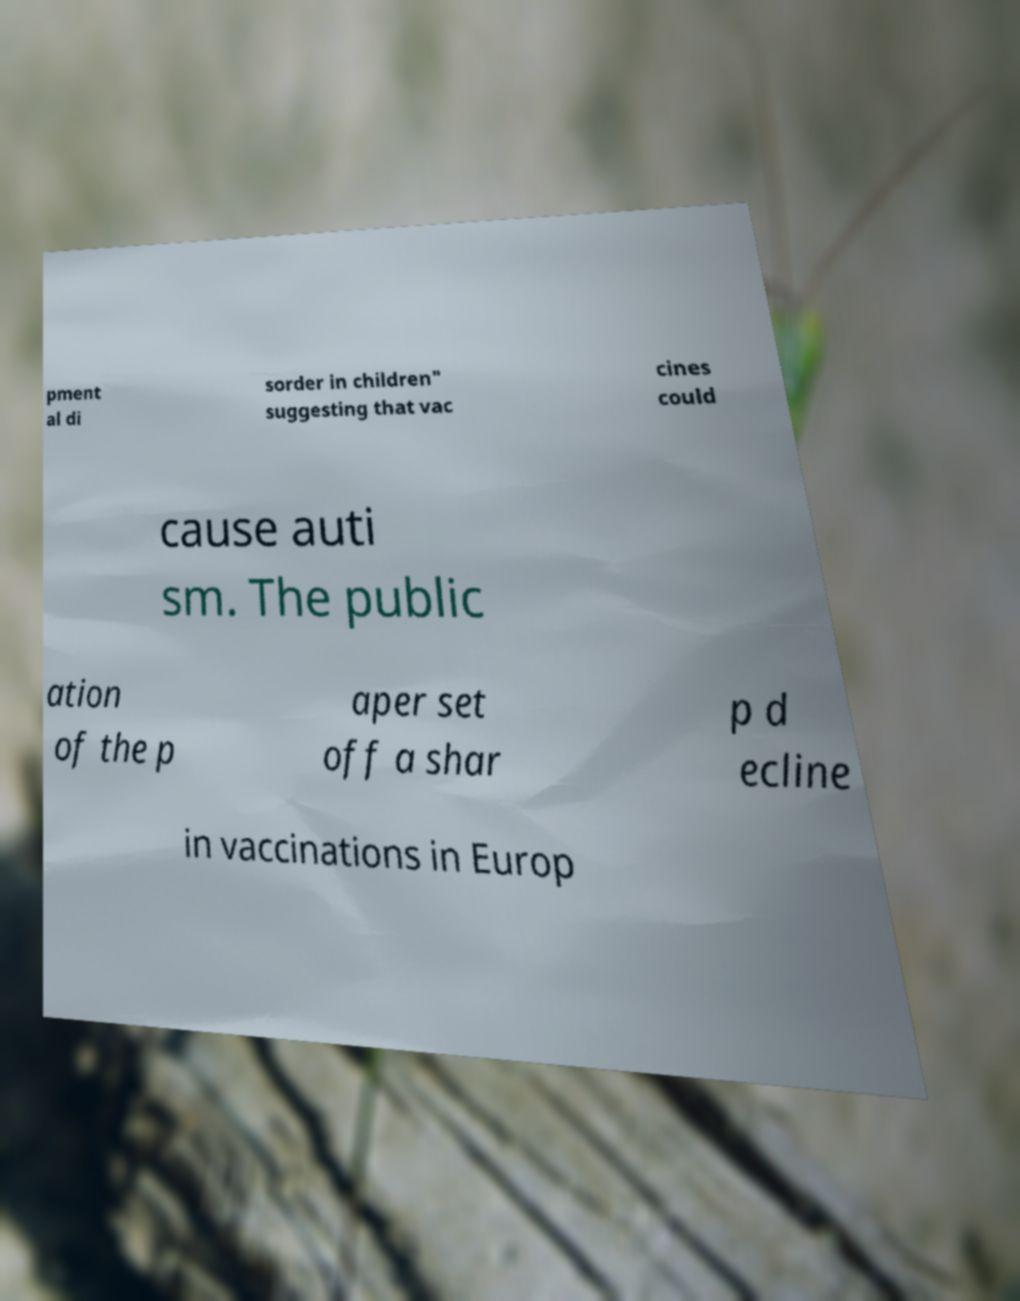Can you read and provide the text displayed in the image?This photo seems to have some interesting text. Can you extract and type it out for me? pment al di sorder in children" suggesting that vac cines could cause auti sm. The public ation of the p aper set off a shar p d ecline in vaccinations in Europ 